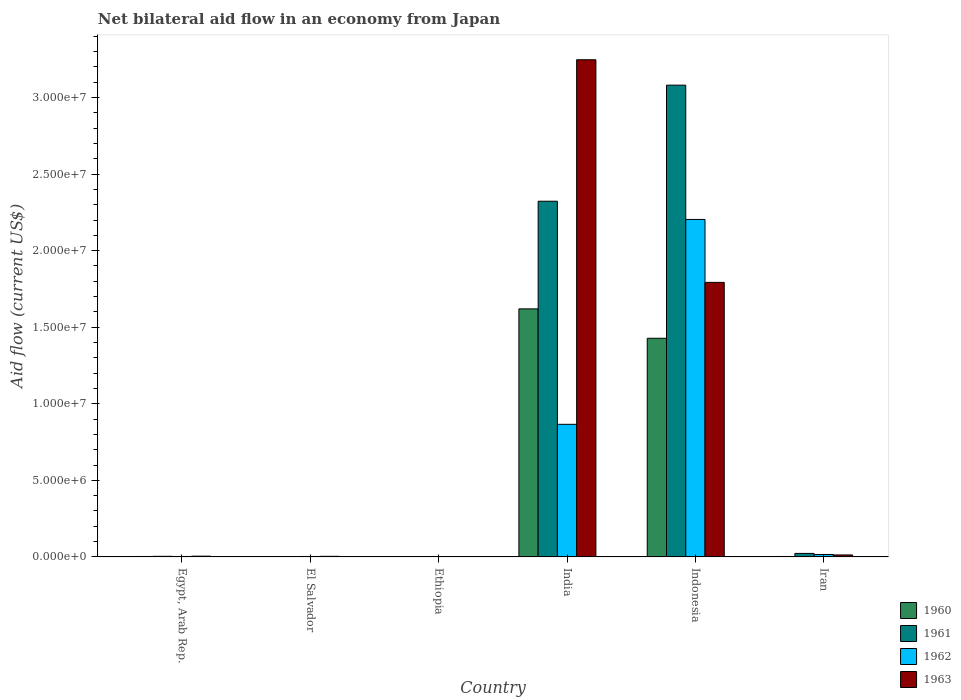How many groups of bars are there?
Your response must be concise. 6. Are the number of bars on each tick of the X-axis equal?
Your response must be concise. Yes. How many bars are there on the 6th tick from the left?
Provide a short and direct response. 4. What is the label of the 4th group of bars from the left?
Keep it short and to the point. India. What is the net bilateral aid flow in 1962 in India?
Offer a terse response. 8.66e+06. Across all countries, what is the maximum net bilateral aid flow in 1960?
Provide a succinct answer. 1.62e+07. In which country was the net bilateral aid flow in 1960 maximum?
Give a very brief answer. India. In which country was the net bilateral aid flow in 1963 minimum?
Make the answer very short. Ethiopia. What is the total net bilateral aid flow in 1962 in the graph?
Your response must be concise. 3.09e+07. What is the difference between the net bilateral aid flow in 1961 in El Salvador and that in India?
Offer a very short reply. -2.32e+07. What is the difference between the net bilateral aid flow in 1960 in Iran and the net bilateral aid flow in 1961 in India?
Provide a short and direct response. -2.32e+07. What is the average net bilateral aid flow in 1962 per country?
Your answer should be very brief. 5.16e+06. What is the difference between the net bilateral aid flow of/in 1963 and net bilateral aid flow of/in 1962 in Ethiopia?
Provide a succinct answer. 0. What is the ratio of the net bilateral aid flow in 1962 in India to that in Indonesia?
Your answer should be very brief. 0.39. Is the net bilateral aid flow in 1963 in El Salvador less than that in Iran?
Offer a terse response. Yes. Is the difference between the net bilateral aid flow in 1963 in Ethiopia and Iran greater than the difference between the net bilateral aid flow in 1962 in Ethiopia and Iran?
Offer a very short reply. Yes. What is the difference between the highest and the second highest net bilateral aid flow in 1963?
Your answer should be compact. 1.45e+07. What is the difference between the highest and the lowest net bilateral aid flow in 1961?
Make the answer very short. 3.08e+07. Is it the case that in every country, the sum of the net bilateral aid flow in 1963 and net bilateral aid flow in 1960 is greater than the sum of net bilateral aid flow in 1962 and net bilateral aid flow in 1961?
Make the answer very short. No. Is it the case that in every country, the sum of the net bilateral aid flow in 1960 and net bilateral aid flow in 1963 is greater than the net bilateral aid flow in 1962?
Give a very brief answer. No. How many countries are there in the graph?
Provide a succinct answer. 6. What is the difference between two consecutive major ticks on the Y-axis?
Provide a succinct answer. 5.00e+06. Are the values on the major ticks of Y-axis written in scientific E-notation?
Offer a terse response. Yes. What is the title of the graph?
Make the answer very short. Net bilateral aid flow in an economy from Japan. Does "2013" appear as one of the legend labels in the graph?
Keep it short and to the point. No. What is the label or title of the X-axis?
Keep it short and to the point. Country. What is the label or title of the Y-axis?
Give a very brief answer. Aid flow (current US$). What is the Aid flow (current US$) of 1961 in Egypt, Arab Rep.?
Offer a very short reply. 4.00e+04. What is the Aid flow (current US$) in 1962 in Egypt, Arab Rep.?
Offer a very short reply. 3.00e+04. What is the Aid flow (current US$) in 1961 in El Salvador?
Offer a very short reply. 10000. What is the Aid flow (current US$) in 1961 in Ethiopia?
Keep it short and to the point. 10000. What is the Aid flow (current US$) of 1962 in Ethiopia?
Your answer should be very brief. 10000. What is the Aid flow (current US$) in 1963 in Ethiopia?
Your answer should be compact. 10000. What is the Aid flow (current US$) of 1960 in India?
Provide a short and direct response. 1.62e+07. What is the Aid flow (current US$) in 1961 in India?
Offer a terse response. 2.32e+07. What is the Aid flow (current US$) of 1962 in India?
Provide a short and direct response. 8.66e+06. What is the Aid flow (current US$) in 1963 in India?
Offer a very short reply. 3.25e+07. What is the Aid flow (current US$) in 1960 in Indonesia?
Offer a very short reply. 1.43e+07. What is the Aid flow (current US$) in 1961 in Indonesia?
Provide a succinct answer. 3.08e+07. What is the Aid flow (current US$) of 1962 in Indonesia?
Keep it short and to the point. 2.20e+07. What is the Aid flow (current US$) of 1963 in Indonesia?
Provide a short and direct response. 1.79e+07. What is the Aid flow (current US$) in 1961 in Iran?
Give a very brief answer. 2.30e+05. What is the Aid flow (current US$) of 1962 in Iran?
Provide a succinct answer. 1.60e+05. What is the Aid flow (current US$) of 1963 in Iran?
Your response must be concise. 1.30e+05. Across all countries, what is the maximum Aid flow (current US$) in 1960?
Provide a succinct answer. 1.62e+07. Across all countries, what is the maximum Aid flow (current US$) of 1961?
Your answer should be very brief. 3.08e+07. Across all countries, what is the maximum Aid flow (current US$) in 1962?
Your answer should be compact. 2.20e+07. Across all countries, what is the maximum Aid flow (current US$) in 1963?
Offer a very short reply. 3.25e+07. Across all countries, what is the minimum Aid flow (current US$) in 1961?
Give a very brief answer. 10000. Across all countries, what is the minimum Aid flow (current US$) in 1962?
Give a very brief answer. 10000. What is the total Aid flow (current US$) in 1960 in the graph?
Offer a very short reply. 3.06e+07. What is the total Aid flow (current US$) of 1961 in the graph?
Provide a succinct answer. 5.43e+07. What is the total Aid flow (current US$) of 1962 in the graph?
Your response must be concise. 3.09e+07. What is the total Aid flow (current US$) of 1963 in the graph?
Provide a short and direct response. 5.06e+07. What is the difference between the Aid flow (current US$) of 1960 in Egypt, Arab Rep. and that in El Salvador?
Provide a short and direct response. 2.00e+04. What is the difference between the Aid flow (current US$) of 1961 in Egypt, Arab Rep. and that in El Salvador?
Provide a succinct answer. 3.00e+04. What is the difference between the Aid flow (current US$) in 1962 in Egypt, Arab Rep. and that in El Salvador?
Give a very brief answer. 0. What is the difference between the Aid flow (current US$) of 1963 in Egypt, Arab Rep. and that in El Salvador?
Give a very brief answer. 10000. What is the difference between the Aid flow (current US$) in 1962 in Egypt, Arab Rep. and that in Ethiopia?
Your answer should be compact. 2.00e+04. What is the difference between the Aid flow (current US$) in 1963 in Egypt, Arab Rep. and that in Ethiopia?
Make the answer very short. 4.00e+04. What is the difference between the Aid flow (current US$) in 1960 in Egypt, Arab Rep. and that in India?
Offer a very short reply. -1.62e+07. What is the difference between the Aid flow (current US$) of 1961 in Egypt, Arab Rep. and that in India?
Give a very brief answer. -2.32e+07. What is the difference between the Aid flow (current US$) of 1962 in Egypt, Arab Rep. and that in India?
Make the answer very short. -8.63e+06. What is the difference between the Aid flow (current US$) in 1963 in Egypt, Arab Rep. and that in India?
Provide a succinct answer. -3.24e+07. What is the difference between the Aid flow (current US$) in 1960 in Egypt, Arab Rep. and that in Indonesia?
Your answer should be very brief. -1.42e+07. What is the difference between the Aid flow (current US$) in 1961 in Egypt, Arab Rep. and that in Indonesia?
Your response must be concise. -3.08e+07. What is the difference between the Aid flow (current US$) of 1962 in Egypt, Arab Rep. and that in Indonesia?
Give a very brief answer. -2.20e+07. What is the difference between the Aid flow (current US$) of 1963 in Egypt, Arab Rep. and that in Indonesia?
Give a very brief answer. -1.79e+07. What is the difference between the Aid flow (current US$) in 1960 in Egypt, Arab Rep. and that in Iran?
Your response must be concise. 0. What is the difference between the Aid flow (current US$) of 1961 in Egypt, Arab Rep. and that in Iran?
Offer a terse response. -1.90e+05. What is the difference between the Aid flow (current US$) of 1963 in Egypt, Arab Rep. and that in Iran?
Offer a terse response. -8.00e+04. What is the difference between the Aid flow (current US$) in 1962 in El Salvador and that in Ethiopia?
Offer a terse response. 2.00e+04. What is the difference between the Aid flow (current US$) of 1960 in El Salvador and that in India?
Provide a short and direct response. -1.62e+07. What is the difference between the Aid flow (current US$) of 1961 in El Salvador and that in India?
Provide a short and direct response. -2.32e+07. What is the difference between the Aid flow (current US$) of 1962 in El Salvador and that in India?
Your answer should be very brief. -8.63e+06. What is the difference between the Aid flow (current US$) of 1963 in El Salvador and that in India?
Provide a short and direct response. -3.24e+07. What is the difference between the Aid flow (current US$) of 1960 in El Salvador and that in Indonesia?
Make the answer very short. -1.43e+07. What is the difference between the Aid flow (current US$) in 1961 in El Salvador and that in Indonesia?
Ensure brevity in your answer.  -3.08e+07. What is the difference between the Aid flow (current US$) of 1962 in El Salvador and that in Indonesia?
Provide a succinct answer. -2.20e+07. What is the difference between the Aid flow (current US$) of 1963 in El Salvador and that in Indonesia?
Ensure brevity in your answer.  -1.79e+07. What is the difference between the Aid flow (current US$) in 1961 in El Salvador and that in Iran?
Offer a very short reply. -2.20e+05. What is the difference between the Aid flow (current US$) of 1962 in El Salvador and that in Iran?
Provide a short and direct response. -1.30e+05. What is the difference between the Aid flow (current US$) of 1963 in El Salvador and that in Iran?
Ensure brevity in your answer.  -9.00e+04. What is the difference between the Aid flow (current US$) of 1960 in Ethiopia and that in India?
Provide a short and direct response. -1.62e+07. What is the difference between the Aid flow (current US$) of 1961 in Ethiopia and that in India?
Your answer should be compact. -2.32e+07. What is the difference between the Aid flow (current US$) of 1962 in Ethiopia and that in India?
Your response must be concise. -8.65e+06. What is the difference between the Aid flow (current US$) of 1963 in Ethiopia and that in India?
Offer a terse response. -3.25e+07. What is the difference between the Aid flow (current US$) in 1960 in Ethiopia and that in Indonesia?
Make the answer very short. -1.43e+07. What is the difference between the Aid flow (current US$) of 1961 in Ethiopia and that in Indonesia?
Offer a terse response. -3.08e+07. What is the difference between the Aid flow (current US$) of 1962 in Ethiopia and that in Indonesia?
Offer a very short reply. -2.20e+07. What is the difference between the Aid flow (current US$) of 1963 in Ethiopia and that in Indonesia?
Make the answer very short. -1.79e+07. What is the difference between the Aid flow (current US$) in 1960 in Ethiopia and that in Iran?
Provide a short and direct response. -2.00e+04. What is the difference between the Aid flow (current US$) of 1962 in Ethiopia and that in Iran?
Your answer should be compact. -1.50e+05. What is the difference between the Aid flow (current US$) of 1963 in Ethiopia and that in Iran?
Provide a short and direct response. -1.20e+05. What is the difference between the Aid flow (current US$) in 1960 in India and that in Indonesia?
Offer a terse response. 1.92e+06. What is the difference between the Aid flow (current US$) of 1961 in India and that in Indonesia?
Offer a very short reply. -7.58e+06. What is the difference between the Aid flow (current US$) in 1962 in India and that in Indonesia?
Your answer should be very brief. -1.34e+07. What is the difference between the Aid flow (current US$) of 1963 in India and that in Indonesia?
Your response must be concise. 1.45e+07. What is the difference between the Aid flow (current US$) in 1960 in India and that in Iran?
Offer a terse response. 1.62e+07. What is the difference between the Aid flow (current US$) of 1961 in India and that in Iran?
Ensure brevity in your answer.  2.30e+07. What is the difference between the Aid flow (current US$) in 1962 in India and that in Iran?
Give a very brief answer. 8.50e+06. What is the difference between the Aid flow (current US$) of 1963 in India and that in Iran?
Your response must be concise. 3.23e+07. What is the difference between the Aid flow (current US$) of 1960 in Indonesia and that in Iran?
Make the answer very short. 1.42e+07. What is the difference between the Aid flow (current US$) in 1961 in Indonesia and that in Iran?
Offer a terse response. 3.06e+07. What is the difference between the Aid flow (current US$) in 1962 in Indonesia and that in Iran?
Give a very brief answer. 2.19e+07. What is the difference between the Aid flow (current US$) in 1963 in Indonesia and that in Iran?
Offer a very short reply. 1.78e+07. What is the difference between the Aid flow (current US$) in 1960 in Egypt, Arab Rep. and the Aid flow (current US$) in 1961 in El Salvador?
Your answer should be compact. 2.00e+04. What is the difference between the Aid flow (current US$) in 1960 in Egypt, Arab Rep. and the Aid flow (current US$) in 1961 in Ethiopia?
Provide a short and direct response. 2.00e+04. What is the difference between the Aid flow (current US$) in 1960 in Egypt, Arab Rep. and the Aid flow (current US$) in 1963 in Ethiopia?
Offer a very short reply. 2.00e+04. What is the difference between the Aid flow (current US$) in 1961 in Egypt, Arab Rep. and the Aid flow (current US$) in 1962 in Ethiopia?
Provide a short and direct response. 3.00e+04. What is the difference between the Aid flow (current US$) of 1961 in Egypt, Arab Rep. and the Aid flow (current US$) of 1963 in Ethiopia?
Your answer should be compact. 3.00e+04. What is the difference between the Aid flow (current US$) of 1960 in Egypt, Arab Rep. and the Aid flow (current US$) of 1961 in India?
Give a very brief answer. -2.32e+07. What is the difference between the Aid flow (current US$) of 1960 in Egypt, Arab Rep. and the Aid flow (current US$) of 1962 in India?
Ensure brevity in your answer.  -8.63e+06. What is the difference between the Aid flow (current US$) in 1960 in Egypt, Arab Rep. and the Aid flow (current US$) in 1963 in India?
Offer a very short reply. -3.24e+07. What is the difference between the Aid flow (current US$) in 1961 in Egypt, Arab Rep. and the Aid flow (current US$) in 1962 in India?
Offer a very short reply. -8.62e+06. What is the difference between the Aid flow (current US$) in 1961 in Egypt, Arab Rep. and the Aid flow (current US$) in 1963 in India?
Your response must be concise. -3.24e+07. What is the difference between the Aid flow (current US$) in 1962 in Egypt, Arab Rep. and the Aid flow (current US$) in 1963 in India?
Ensure brevity in your answer.  -3.24e+07. What is the difference between the Aid flow (current US$) in 1960 in Egypt, Arab Rep. and the Aid flow (current US$) in 1961 in Indonesia?
Your answer should be very brief. -3.08e+07. What is the difference between the Aid flow (current US$) of 1960 in Egypt, Arab Rep. and the Aid flow (current US$) of 1962 in Indonesia?
Your answer should be compact. -2.20e+07. What is the difference between the Aid flow (current US$) in 1960 in Egypt, Arab Rep. and the Aid flow (current US$) in 1963 in Indonesia?
Offer a terse response. -1.79e+07. What is the difference between the Aid flow (current US$) in 1961 in Egypt, Arab Rep. and the Aid flow (current US$) in 1962 in Indonesia?
Give a very brief answer. -2.20e+07. What is the difference between the Aid flow (current US$) in 1961 in Egypt, Arab Rep. and the Aid flow (current US$) in 1963 in Indonesia?
Give a very brief answer. -1.79e+07. What is the difference between the Aid flow (current US$) of 1962 in Egypt, Arab Rep. and the Aid flow (current US$) of 1963 in Indonesia?
Provide a short and direct response. -1.79e+07. What is the difference between the Aid flow (current US$) of 1960 in Egypt, Arab Rep. and the Aid flow (current US$) of 1961 in Iran?
Make the answer very short. -2.00e+05. What is the difference between the Aid flow (current US$) of 1960 in Egypt, Arab Rep. and the Aid flow (current US$) of 1963 in Iran?
Provide a short and direct response. -1.00e+05. What is the difference between the Aid flow (current US$) in 1961 in Egypt, Arab Rep. and the Aid flow (current US$) in 1963 in Iran?
Provide a succinct answer. -9.00e+04. What is the difference between the Aid flow (current US$) in 1962 in Egypt, Arab Rep. and the Aid flow (current US$) in 1963 in Iran?
Your answer should be very brief. -1.00e+05. What is the difference between the Aid flow (current US$) in 1961 in El Salvador and the Aid flow (current US$) in 1963 in Ethiopia?
Provide a succinct answer. 0. What is the difference between the Aid flow (current US$) of 1960 in El Salvador and the Aid flow (current US$) of 1961 in India?
Give a very brief answer. -2.32e+07. What is the difference between the Aid flow (current US$) of 1960 in El Salvador and the Aid flow (current US$) of 1962 in India?
Your answer should be compact. -8.65e+06. What is the difference between the Aid flow (current US$) in 1960 in El Salvador and the Aid flow (current US$) in 1963 in India?
Your answer should be compact. -3.25e+07. What is the difference between the Aid flow (current US$) of 1961 in El Salvador and the Aid flow (current US$) of 1962 in India?
Provide a short and direct response. -8.65e+06. What is the difference between the Aid flow (current US$) in 1961 in El Salvador and the Aid flow (current US$) in 1963 in India?
Keep it short and to the point. -3.25e+07. What is the difference between the Aid flow (current US$) of 1962 in El Salvador and the Aid flow (current US$) of 1963 in India?
Ensure brevity in your answer.  -3.24e+07. What is the difference between the Aid flow (current US$) in 1960 in El Salvador and the Aid flow (current US$) in 1961 in Indonesia?
Your response must be concise. -3.08e+07. What is the difference between the Aid flow (current US$) in 1960 in El Salvador and the Aid flow (current US$) in 1962 in Indonesia?
Give a very brief answer. -2.20e+07. What is the difference between the Aid flow (current US$) of 1960 in El Salvador and the Aid flow (current US$) of 1963 in Indonesia?
Offer a very short reply. -1.79e+07. What is the difference between the Aid flow (current US$) in 1961 in El Salvador and the Aid flow (current US$) in 1962 in Indonesia?
Your response must be concise. -2.20e+07. What is the difference between the Aid flow (current US$) in 1961 in El Salvador and the Aid flow (current US$) in 1963 in Indonesia?
Ensure brevity in your answer.  -1.79e+07. What is the difference between the Aid flow (current US$) in 1962 in El Salvador and the Aid flow (current US$) in 1963 in Indonesia?
Provide a succinct answer. -1.79e+07. What is the difference between the Aid flow (current US$) of 1960 in El Salvador and the Aid flow (current US$) of 1961 in Iran?
Your response must be concise. -2.20e+05. What is the difference between the Aid flow (current US$) in 1960 in El Salvador and the Aid flow (current US$) in 1963 in Iran?
Make the answer very short. -1.20e+05. What is the difference between the Aid flow (current US$) of 1961 in El Salvador and the Aid flow (current US$) of 1962 in Iran?
Offer a very short reply. -1.50e+05. What is the difference between the Aid flow (current US$) in 1961 in El Salvador and the Aid flow (current US$) in 1963 in Iran?
Your answer should be compact. -1.20e+05. What is the difference between the Aid flow (current US$) in 1962 in El Salvador and the Aid flow (current US$) in 1963 in Iran?
Make the answer very short. -1.00e+05. What is the difference between the Aid flow (current US$) of 1960 in Ethiopia and the Aid flow (current US$) of 1961 in India?
Give a very brief answer. -2.32e+07. What is the difference between the Aid flow (current US$) in 1960 in Ethiopia and the Aid flow (current US$) in 1962 in India?
Provide a succinct answer. -8.65e+06. What is the difference between the Aid flow (current US$) of 1960 in Ethiopia and the Aid flow (current US$) of 1963 in India?
Your answer should be very brief. -3.25e+07. What is the difference between the Aid flow (current US$) of 1961 in Ethiopia and the Aid flow (current US$) of 1962 in India?
Your response must be concise. -8.65e+06. What is the difference between the Aid flow (current US$) in 1961 in Ethiopia and the Aid flow (current US$) in 1963 in India?
Ensure brevity in your answer.  -3.25e+07. What is the difference between the Aid flow (current US$) in 1962 in Ethiopia and the Aid flow (current US$) in 1963 in India?
Keep it short and to the point. -3.25e+07. What is the difference between the Aid flow (current US$) of 1960 in Ethiopia and the Aid flow (current US$) of 1961 in Indonesia?
Give a very brief answer. -3.08e+07. What is the difference between the Aid flow (current US$) in 1960 in Ethiopia and the Aid flow (current US$) in 1962 in Indonesia?
Your response must be concise. -2.20e+07. What is the difference between the Aid flow (current US$) of 1960 in Ethiopia and the Aid flow (current US$) of 1963 in Indonesia?
Your answer should be compact. -1.79e+07. What is the difference between the Aid flow (current US$) of 1961 in Ethiopia and the Aid flow (current US$) of 1962 in Indonesia?
Offer a terse response. -2.20e+07. What is the difference between the Aid flow (current US$) in 1961 in Ethiopia and the Aid flow (current US$) in 1963 in Indonesia?
Your response must be concise. -1.79e+07. What is the difference between the Aid flow (current US$) of 1962 in Ethiopia and the Aid flow (current US$) of 1963 in Indonesia?
Offer a very short reply. -1.79e+07. What is the difference between the Aid flow (current US$) in 1960 in Ethiopia and the Aid flow (current US$) in 1961 in Iran?
Your answer should be very brief. -2.20e+05. What is the difference between the Aid flow (current US$) of 1960 in Ethiopia and the Aid flow (current US$) of 1963 in Iran?
Offer a terse response. -1.20e+05. What is the difference between the Aid flow (current US$) of 1961 in Ethiopia and the Aid flow (current US$) of 1962 in Iran?
Your answer should be compact. -1.50e+05. What is the difference between the Aid flow (current US$) in 1962 in Ethiopia and the Aid flow (current US$) in 1963 in Iran?
Offer a very short reply. -1.20e+05. What is the difference between the Aid flow (current US$) in 1960 in India and the Aid flow (current US$) in 1961 in Indonesia?
Offer a terse response. -1.46e+07. What is the difference between the Aid flow (current US$) of 1960 in India and the Aid flow (current US$) of 1962 in Indonesia?
Provide a short and direct response. -5.84e+06. What is the difference between the Aid flow (current US$) in 1960 in India and the Aid flow (current US$) in 1963 in Indonesia?
Your answer should be compact. -1.73e+06. What is the difference between the Aid flow (current US$) of 1961 in India and the Aid flow (current US$) of 1962 in Indonesia?
Your answer should be compact. 1.19e+06. What is the difference between the Aid flow (current US$) in 1961 in India and the Aid flow (current US$) in 1963 in Indonesia?
Your answer should be compact. 5.30e+06. What is the difference between the Aid flow (current US$) in 1962 in India and the Aid flow (current US$) in 1963 in Indonesia?
Offer a terse response. -9.27e+06. What is the difference between the Aid flow (current US$) in 1960 in India and the Aid flow (current US$) in 1961 in Iran?
Your response must be concise. 1.60e+07. What is the difference between the Aid flow (current US$) of 1960 in India and the Aid flow (current US$) of 1962 in Iran?
Provide a short and direct response. 1.60e+07. What is the difference between the Aid flow (current US$) in 1960 in India and the Aid flow (current US$) in 1963 in Iran?
Your answer should be very brief. 1.61e+07. What is the difference between the Aid flow (current US$) in 1961 in India and the Aid flow (current US$) in 1962 in Iran?
Ensure brevity in your answer.  2.31e+07. What is the difference between the Aid flow (current US$) in 1961 in India and the Aid flow (current US$) in 1963 in Iran?
Your answer should be compact. 2.31e+07. What is the difference between the Aid flow (current US$) of 1962 in India and the Aid flow (current US$) of 1963 in Iran?
Offer a terse response. 8.53e+06. What is the difference between the Aid flow (current US$) in 1960 in Indonesia and the Aid flow (current US$) in 1961 in Iran?
Offer a very short reply. 1.40e+07. What is the difference between the Aid flow (current US$) in 1960 in Indonesia and the Aid flow (current US$) in 1962 in Iran?
Your answer should be very brief. 1.41e+07. What is the difference between the Aid flow (current US$) of 1960 in Indonesia and the Aid flow (current US$) of 1963 in Iran?
Your response must be concise. 1.42e+07. What is the difference between the Aid flow (current US$) in 1961 in Indonesia and the Aid flow (current US$) in 1962 in Iran?
Give a very brief answer. 3.06e+07. What is the difference between the Aid flow (current US$) in 1961 in Indonesia and the Aid flow (current US$) in 1963 in Iran?
Provide a succinct answer. 3.07e+07. What is the difference between the Aid flow (current US$) of 1962 in Indonesia and the Aid flow (current US$) of 1963 in Iran?
Offer a terse response. 2.19e+07. What is the average Aid flow (current US$) of 1960 per country?
Provide a short and direct response. 5.09e+06. What is the average Aid flow (current US$) of 1961 per country?
Your answer should be very brief. 9.06e+06. What is the average Aid flow (current US$) of 1962 per country?
Your answer should be compact. 5.16e+06. What is the average Aid flow (current US$) in 1963 per country?
Make the answer very short. 8.44e+06. What is the difference between the Aid flow (current US$) of 1960 and Aid flow (current US$) of 1963 in Egypt, Arab Rep.?
Offer a terse response. -2.00e+04. What is the difference between the Aid flow (current US$) in 1960 and Aid flow (current US$) in 1961 in El Salvador?
Provide a short and direct response. 0. What is the difference between the Aid flow (current US$) of 1960 and Aid flow (current US$) of 1962 in El Salvador?
Ensure brevity in your answer.  -2.00e+04. What is the difference between the Aid flow (current US$) of 1960 and Aid flow (current US$) of 1963 in El Salvador?
Keep it short and to the point. -3.00e+04. What is the difference between the Aid flow (current US$) in 1961 and Aid flow (current US$) in 1963 in El Salvador?
Provide a succinct answer. -3.00e+04. What is the difference between the Aid flow (current US$) of 1962 and Aid flow (current US$) of 1963 in El Salvador?
Provide a succinct answer. -10000. What is the difference between the Aid flow (current US$) in 1960 and Aid flow (current US$) in 1962 in Ethiopia?
Your answer should be very brief. 0. What is the difference between the Aid flow (current US$) of 1960 and Aid flow (current US$) of 1963 in Ethiopia?
Give a very brief answer. 0. What is the difference between the Aid flow (current US$) in 1961 and Aid flow (current US$) in 1962 in Ethiopia?
Your answer should be compact. 0. What is the difference between the Aid flow (current US$) of 1962 and Aid flow (current US$) of 1963 in Ethiopia?
Keep it short and to the point. 0. What is the difference between the Aid flow (current US$) in 1960 and Aid flow (current US$) in 1961 in India?
Your answer should be very brief. -7.03e+06. What is the difference between the Aid flow (current US$) in 1960 and Aid flow (current US$) in 1962 in India?
Provide a succinct answer. 7.54e+06. What is the difference between the Aid flow (current US$) in 1960 and Aid flow (current US$) in 1963 in India?
Offer a very short reply. -1.63e+07. What is the difference between the Aid flow (current US$) of 1961 and Aid flow (current US$) of 1962 in India?
Make the answer very short. 1.46e+07. What is the difference between the Aid flow (current US$) in 1961 and Aid flow (current US$) in 1963 in India?
Offer a very short reply. -9.24e+06. What is the difference between the Aid flow (current US$) in 1962 and Aid flow (current US$) in 1963 in India?
Ensure brevity in your answer.  -2.38e+07. What is the difference between the Aid flow (current US$) in 1960 and Aid flow (current US$) in 1961 in Indonesia?
Give a very brief answer. -1.65e+07. What is the difference between the Aid flow (current US$) in 1960 and Aid flow (current US$) in 1962 in Indonesia?
Provide a succinct answer. -7.76e+06. What is the difference between the Aid flow (current US$) of 1960 and Aid flow (current US$) of 1963 in Indonesia?
Give a very brief answer. -3.65e+06. What is the difference between the Aid flow (current US$) in 1961 and Aid flow (current US$) in 1962 in Indonesia?
Your answer should be very brief. 8.77e+06. What is the difference between the Aid flow (current US$) in 1961 and Aid flow (current US$) in 1963 in Indonesia?
Your answer should be compact. 1.29e+07. What is the difference between the Aid flow (current US$) of 1962 and Aid flow (current US$) of 1963 in Indonesia?
Keep it short and to the point. 4.11e+06. What is the difference between the Aid flow (current US$) of 1960 and Aid flow (current US$) of 1961 in Iran?
Your response must be concise. -2.00e+05. What is the difference between the Aid flow (current US$) of 1960 and Aid flow (current US$) of 1962 in Iran?
Offer a terse response. -1.30e+05. What is the difference between the Aid flow (current US$) in 1961 and Aid flow (current US$) in 1963 in Iran?
Provide a short and direct response. 1.00e+05. What is the difference between the Aid flow (current US$) of 1962 and Aid flow (current US$) of 1963 in Iran?
Your response must be concise. 3.00e+04. What is the ratio of the Aid flow (current US$) of 1960 in Egypt, Arab Rep. to that in El Salvador?
Your answer should be compact. 3. What is the ratio of the Aid flow (current US$) in 1962 in Egypt, Arab Rep. to that in El Salvador?
Ensure brevity in your answer.  1. What is the ratio of the Aid flow (current US$) in 1962 in Egypt, Arab Rep. to that in Ethiopia?
Provide a succinct answer. 3. What is the ratio of the Aid flow (current US$) of 1963 in Egypt, Arab Rep. to that in Ethiopia?
Your response must be concise. 5. What is the ratio of the Aid flow (current US$) in 1960 in Egypt, Arab Rep. to that in India?
Provide a short and direct response. 0. What is the ratio of the Aid flow (current US$) in 1961 in Egypt, Arab Rep. to that in India?
Offer a terse response. 0. What is the ratio of the Aid flow (current US$) of 1962 in Egypt, Arab Rep. to that in India?
Provide a succinct answer. 0. What is the ratio of the Aid flow (current US$) of 1963 in Egypt, Arab Rep. to that in India?
Provide a short and direct response. 0. What is the ratio of the Aid flow (current US$) of 1960 in Egypt, Arab Rep. to that in Indonesia?
Provide a succinct answer. 0. What is the ratio of the Aid flow (current US$) of 1961 in Egypt, Arab Rep. to that in Indonesia?
Your answer should be very brief. 0. What is the ratio of the Aid flow (current US$) in 1962 in Egypt, Arab Rep. to that in Indonesia?
Your response must be concise. 0. What is the ratio of the Aid flow (current US$) of 1963 in Egypt, Arab Rep. to that in Indonesia?
Your response must be concise. 0. What is the ratio of the Aid flow (current US$) of 1961 in Egypt, Arab Rep. to that in Iran?
Offer a very short reply. 0.17. What is the ratio of the Aid flow (current US$) of 1962 in Egypt, Arab Rep. to that in Iran?
Your answer should be compact. 0.19. What is the ratio of the Aid flow (current US$) in 1963 in Egypt, Arab Rep. to that in Iran?
Your answer should be very brief. 0.38. What is the ratio of the Aid flow (current US$) in 1961 in El Salvador to that in Ethiopia?
Your answer should be very brief. 1. What is the ratio of the Aid flow (current US$) of 1960 in El Salvador to that in India?
Offer a very short reply. 0. What is the ratio of the Aid flow (current US$) in 1961 in El Salvador to that in India?
Ensure brevity in your answer.  0. What is the ratio of the Aid flow (current US$) of 1962 in El Salvador to that in India?
Keep it short and to the point. 0. What is the ratio of the Aid flow (current US$) in 1963 in El Salvador to that in India?
Make the answer very short. 0. What is the ratio of the Aid flow (current US$) in 1960 in El Salvador to that in Indonesia?
Ensure brevity in your answer.  0. What is the ratio of the Aid flow (current US$) of 1961 in El Salvador to that in Indonesia?
Provide a succinct answer. 0. What is the ratio of the Aid flow (current US$) of 1962 in El Salvador to that in Indonesia?
Offer a terse response. 0. What is the ratio of the Aid flow (current US$) of 1963 in El Salvador to that in Indonesia?
Ensure brevity in your answer.  0. What is the ratio of the Aid flow (current US$) in 1961 in El Salvador to that in Iran?
Make the answer very short. 0.04. What is the ratio of the Aid flow (current US$) in 1962 in El Salvador to that in Iran?
Your answer should be very brief. 0.19. What is the ratio of the Aid flow (current US$) in 1963 in El Salvador to that in Iran?
Your answer should be compact. 0.31. What is the ratio of the Aid flow (current US$) of 1960 in Ethiopia to that in India?
Make the answer very short. 0. What is the ratio of the Aid flow (current US$) of 1961 in Ethiopia to that in India?
Provide a short and direct response. 0. What is the ratio of the Aid flow (current US$) in 1962 in Ethiopia to that in India?
Give a very brief answer. 0. What is the ratio of the Aid flow (current US$) of 1960 in Ethiopia to that in Indonesia?
Keep it short and to the point. 0. What is the ratio of the Aid flow (current US$) of 1963 in Ethiopia to that in Indonesia?
Your response must be concise. 0. What is the ratio of the Aid flow (current US$) in 1961 in Ethiopia to that in Iran?
Provide a succinct answer. 0.04. What is the ratio of the Aid flow (current US$) of 1962 in Ethiopia to that in Iran?
Ensure brevity in your answer.  0.06. What is the ratio of the Aid flow (current US$) of 1963 in Ethiopia to that in Iran?
Make the answer very short. 0.08. What is the ratio of the Aid flow (current US$) in 1960 in India to that in Indonesia?
Your response must be concise. 1.13. What is the ratio of the Aid flow (current US$) of 1961 in India to that in Indonesia?
Give a very brief answer. 0.75. What is the ratio of the Aid flow (current US$) in 1962 in India to that in Indonesia?
Provide a succinct answer. 0.39. What is the ratio of the Aid flow (current US$) of 1963 in India to that in Indonesia?
Make the answer very short. 1.81. What is the ratio of the Aid flow (current US$) in 1960 in India to that in Iran?
Provide a succinct answer. 540. What is the ratio of the Aid flow (current US$) in 1961 in India to that in Iran?
Your response must be concise. 101. What is the ratio of the Aid flow (current US$) in 1962 in India to that in Iran?
Your answer should be very brief. 54.12. What is the ratio of the Aid flow (current US$) in 1963 in India to that in Iran?
Offer a very short reply. 249.77. What is the ratio of the Aid flow (current US$) of 1960 in Indonesia to that in Iran?
Your answer should be compact. 476. What is the ratio of the Aid flow (current US$) in 1961 in Indonesia to that in Iran?
Provide a short and direct response. 133.96. What is the ratio of the Aid flow (current US$) of 1962 in Indonesia to that in Iran?
Give a very brief answer. 137.75. What is the ratio of the Aid flow (current US$) of 1963 in Indonesia to that in Iran?
Ensure brevity in your answer.  137.92. What is the difference between the highest and the second highest Aid flow (current US$) in 1960?
Your answer should be very brief. 1.92e+06. What is the difference between the highest and the second highest Aid flow (current US$) in 1961?
Your response must be concise. 7.58e+06. What is the difference between the highest and the second highest Aid flow (current US$) of 1962?
Your answer should be compact. 1.34e+07. What is the difference between the highest and the second highest Aid flow (current US$) in 1963?
Provide a short and direct response. 1.45e+07. What is the difference between the highest and the lowest Aid flow (current US$) in 1960?
Your response must be concise. 1.62e+07. What is the difference between the highest and the lowest Aid flow (current US$) in 1961?
Provide a short and direct response. 3.08e+07. What is the difference between the highest and the lowest Aid flow (current US$) of 1962?
Your answer should be very brief. 2.20e+07. What is the difference between the highest and the lowest Aid flow (current US$) of 1963?
Ensure brevity in your answer.  3.25e+07. 